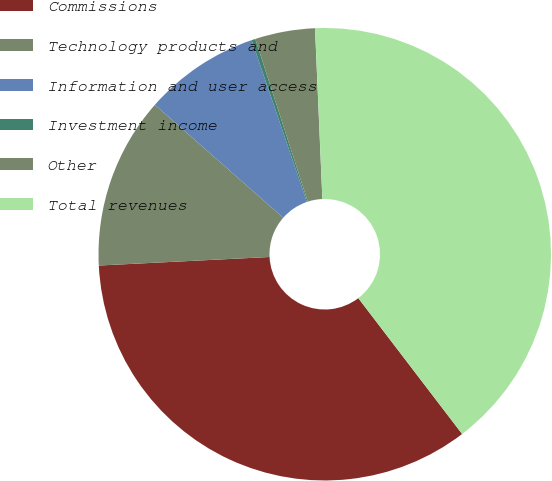Convert chart. <chart><loc_0><loc_0><loc_500><loc_500><pie_chart><fcel>Commissions<fcel>Technology products and<fcel>Information and user access<fcel>Investment income<fcel>Other<fcel>Total revenues<nl><fcel>34.59%<fcel>12.28%<fcel>8.28%<fcel>0.27%<fcel>4.28%<fcel>40.3%<nl></chart> 